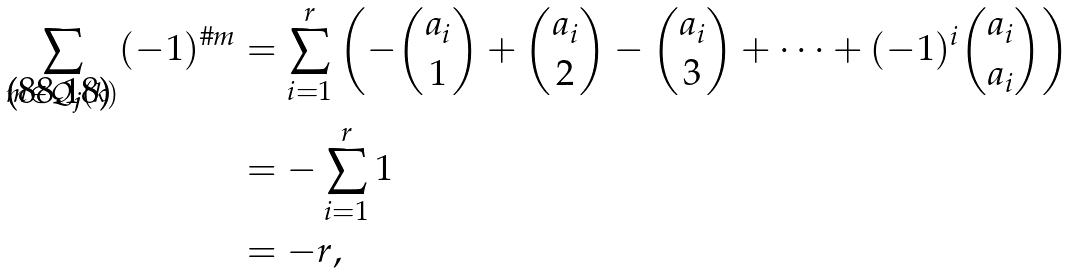<formula> <loc_0><loc_0><loc_500><loc_500>\sum _ { m \in \mathcal { Q } _ { \text {\boldmath$j$} } ( k ) } ( - 1 ) ^ { \# m } & = \sum _ { i = 1 } ^ { r } \left ( - \binom { a _ { i } } { 1 } + \binom { a _ { i } } { 2 } - \binom { a _ { i } } { 3 } + \cdots + ( - 1 ) ^ { i } \binom { a _ { i } } { a _ { i } } \right ) \\ & = - \sum _ { i = 1 } ^ { r } 1 \\ & = - r ,</formula> 